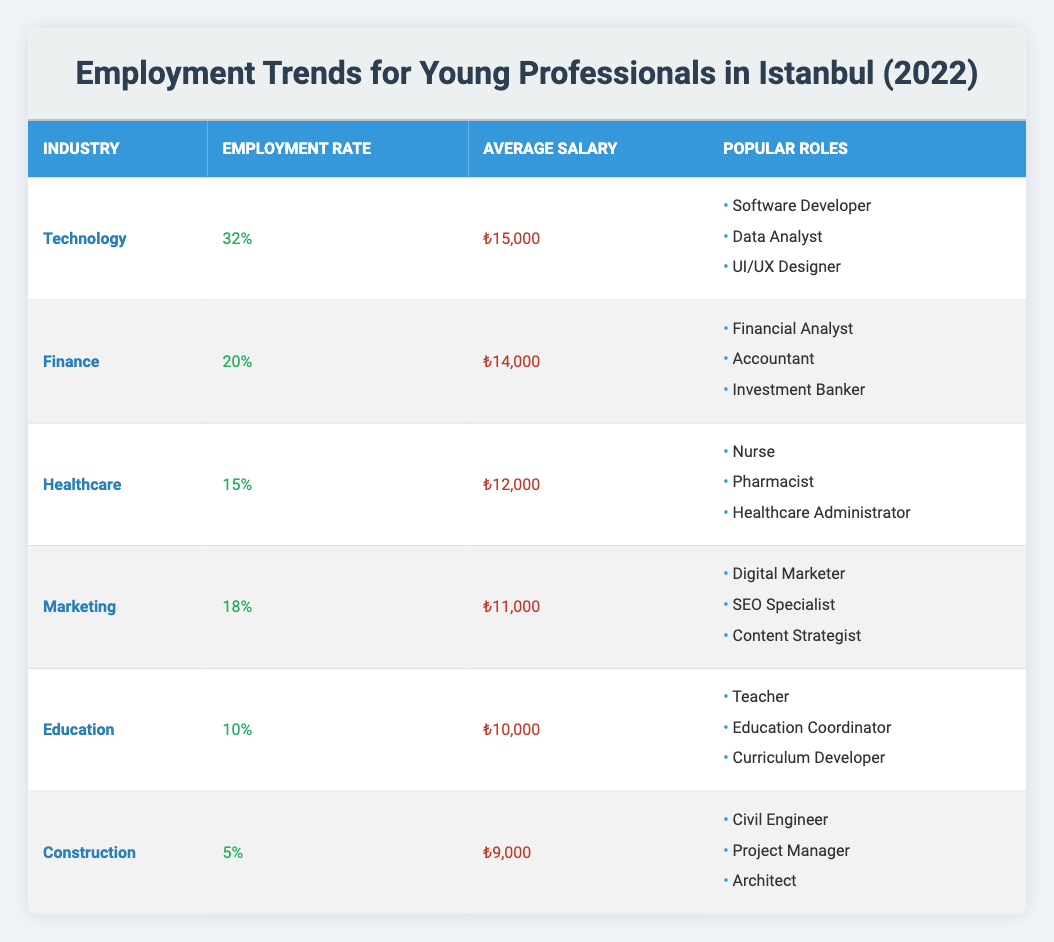What is the employment rate for the Technology industry? The table shows that the employment rate for the Technology industry is listed directly under the "Employment Rate" column beside "Technology." The specific value is 32%.
Answer: 32% Which industry has the highest average salary? To determine which industry has the highest average salary, we can compare the values listed in the "Average Salary" column. The Technology industry shows an average salary of ₺15,000, which is higher than all other listed industries.
Answer: Technology What is the combined employment rate for Finance and Healthcare? The employment rate for Finance is 20% and for Healthcare is 15%. By adding these two rates (20% + 15%), we find the combined employment rate to be 35%.
Answer: 35% Is the average salary for Marketing higher than that of Education? The average salary for Marketing is ₺11,000 and for Education, it is ₺10,000. Since ₺11,000 is greater than ₺10,000, we can confirm that the average salary for Marketing is indeed higher.
Answer: Yes What percentage of employed young professionals work in Construction? The table indicates that the Employment Rate for the Construction industry is 5%. This value is found directly in the Employment Rate column next to the Construction entry.
Answer: 5% If an individual works in the Technology industry, how much more can they expect to earn on average compared to someone in the Education sector? The average salary for a Technology professional is ₺15,000, while for Education, it is ₺10,000. The difference is ₺15,000 - ₺10,000 = ₺5,000, showing a higher earning potential in Technology.
Answer: ₺5,000 Which popular role is associated with the Marketing industry? From the table, the popular roles listed under the Marketing industry include Digital Marketer, SEO Specialist, and Content Strategist. These roles can be found in the "Popular Roles" section corresponding to Marketing.
Answer: Digital Marketer, SEO Specialist, Content Strategist Is it true that more than 30% of young professionals are employed in Technology? The table states that the employment rate for the Technology industry is 32%. Since this is greater than 30%, the answer is yes.
Answer: Yes What is the average salary across all listed industries? To find the average salary, we first sum the average salaries: ₺15,000 (Technology) + ₺14,000 (Finance) + ₺12,000 (Healthcare) + ₺11,000 (Marketing) + ₺10,000 (Education) + ₺9,000 (Construction) = ₺71,000. We then divide this total by the number of industries (6), giving us an average of ₺71,000 / 6 = ₺11,833.33.
Answer: ₺11,833.33 